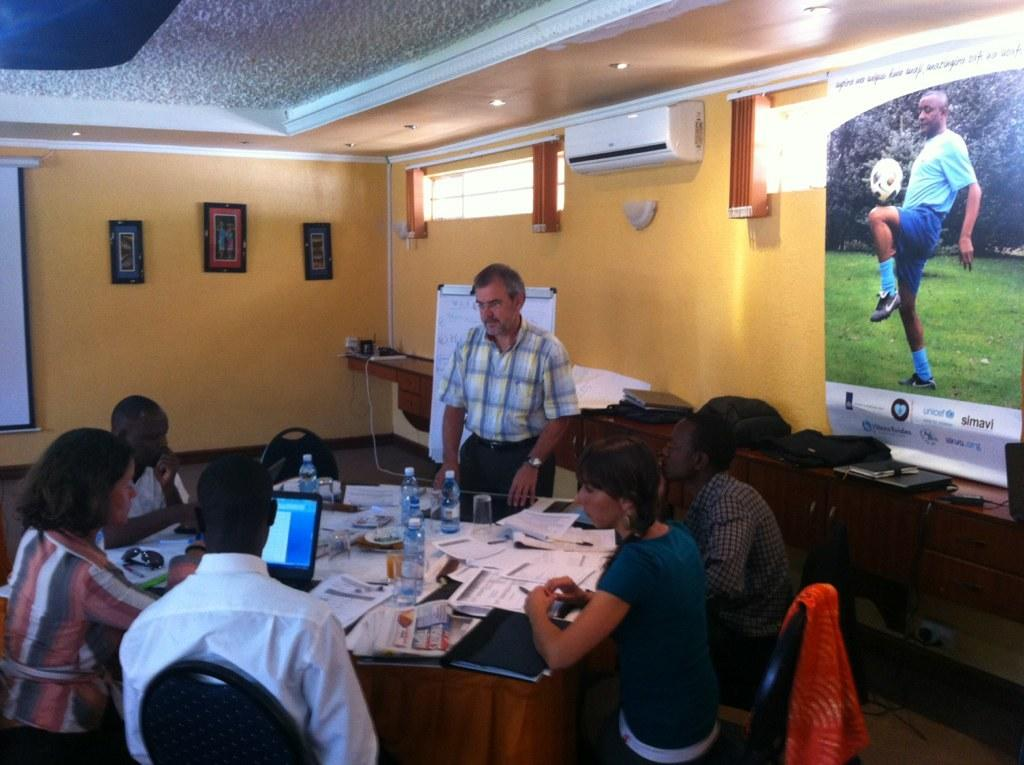What are the people in the image doing? The people in the image are sitting on chairs. What is on the table in the image? There is a laptop and papers on the table. What is the man in the image doing? The man is standing in the image. How does the boy in the image help with the current situation? There is no boy present in the image, so it is not possible to answer this question. 